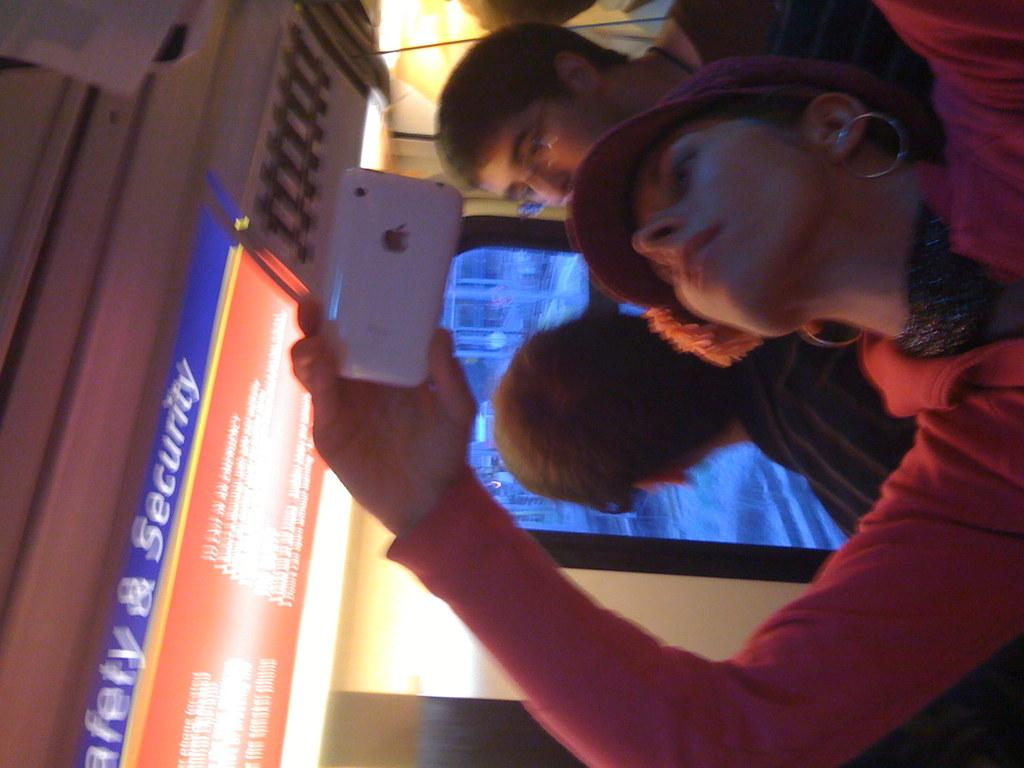What can be seen on the right side of the image? There is a person on the right side of the image. What is the person wearing? The person is wearing something. What is the person holding in her hand? The person is holding a mobile with her hand. How many persons are in front of the window? There are two persons in front of the window. Where is the window located in the image? The window is in the middle of the image. What color is the sock on the hydrant in the image? There is no sock or hydrant present in the image. Is the house in the image made of bricks or wood? The provided facts do not mention a house, so we cannot determine its construction material. 